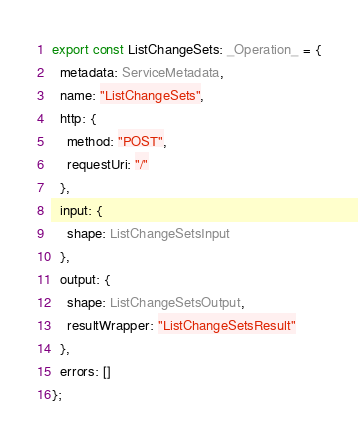<code> <loc_0><loc_0><loc_500><loc_500><_TypeScript_>export const ListChangeSets: _Operation_ = {
  metadata: ServiceMetadata,
  name: "ListChangeSets",
  http: {
    method: "POST",
    requestUri: "/"
  },
  input: {
    shape: ListChangeSetsInput
  },
  output: {
    shape: ListChangeSetsOutput,
    resultWrapper: "ListChangeSetsResult"
  },
  errors: []
};
</code> 